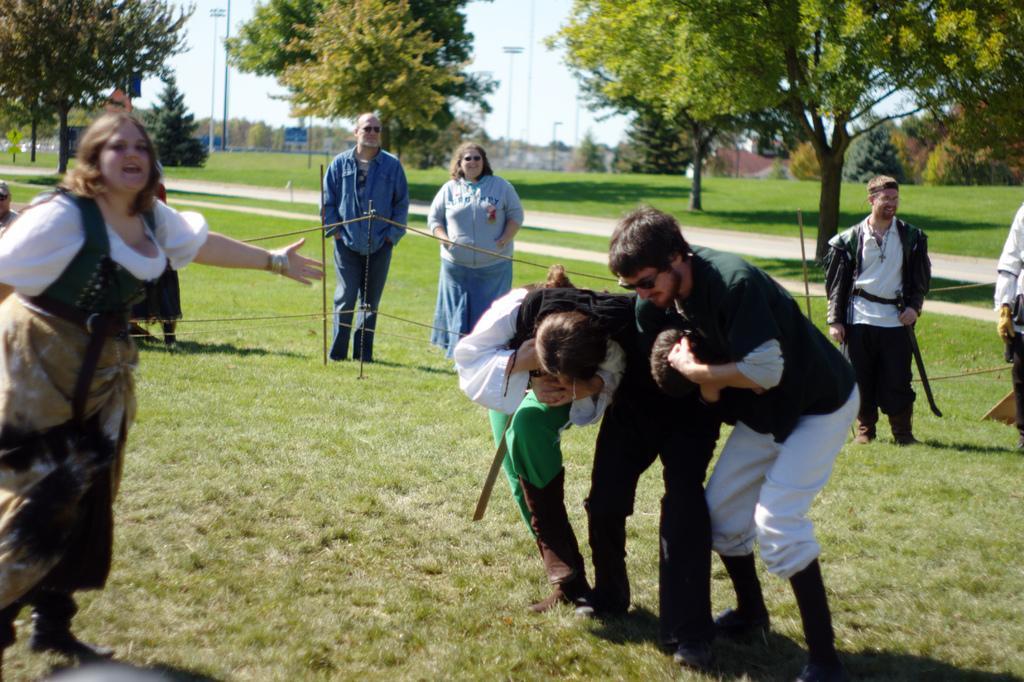Please provide a concise description of this image. There are few people standing. This is the grass. These are the trees with branches and leaves. I think this is the pathway. In the background, I can see the poles. 